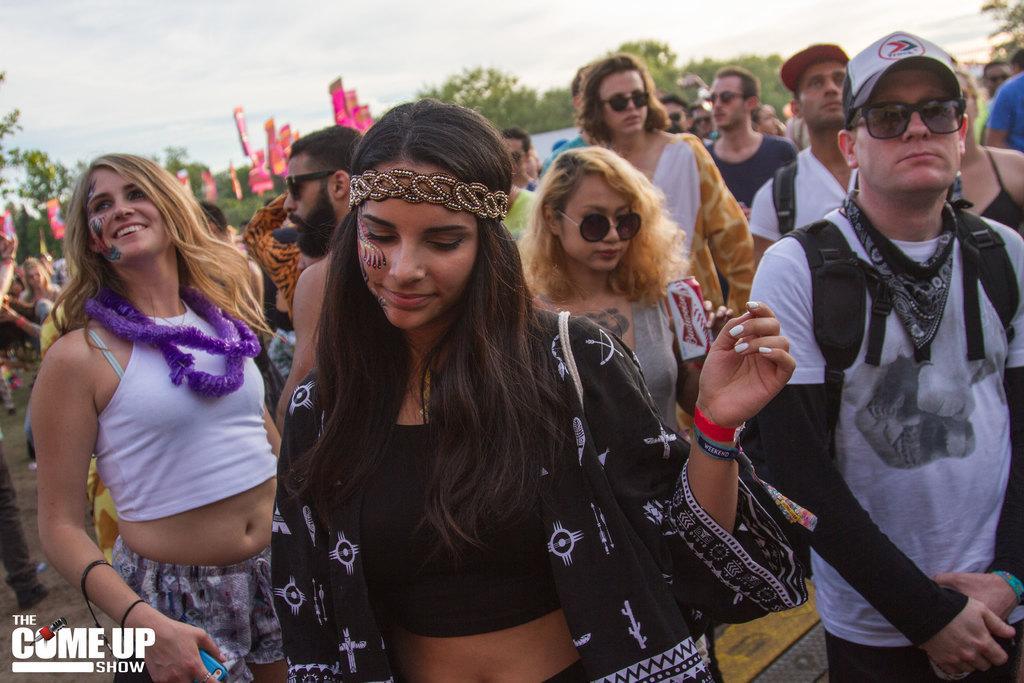Could you give a brief overview of what you see in this image? In this image there are couple of persons are standing as we can see in middle of this image and there are some trees in the background and there is a sky at top of this image and there is watermark at bottom left corner of this image. 